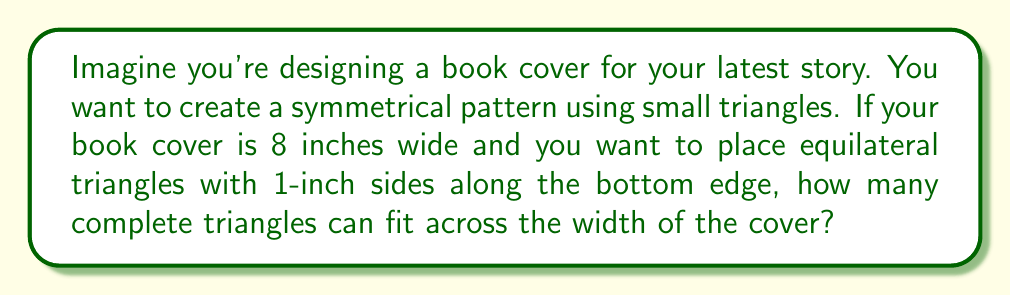Give your solution to this math problem. Let's approach this step-by-step:

1. We need to find out how much space each triangle occupies horizontally.

2. In an equilateral triangle, all sides are equal and all angles are 60°.

3. The width of the triangle is not the same as its side length. We need to calculate it:
   
   [asy]
   import geometry;
   
   size(100);
   
   pair A = (0,0), B = (1,0), C = (0.5, 0.866);
   
   draw(A--B--C--A);
   
   label("1", (B+C)/2, E);
   label("0.5", (0.25, 0), S);
   label("$\frac{\sqrt{3}}{2}$", (0.5,0.433), W);
   
   dot("A", A, SW);
   dot("B", B, SE);
   dot("C", C, N);
   [/asy]

4. The width of each triangle is equal to the side length multiplied by $\cos 30°$:
   
   $\text{Width} = 1 \cdot \cos 30° = 1 \cdot \frac{\sqrt{3}}{2} \approx 0.866$ inches

5. Now we can calculate how many triangles fit in 8 inches:
   
   $\text{Number of triangles} = \frac{\text{Total width}}{\text{Width of one triangle}} = \frac{8}{\frac{\sqrt{3}}{2}}$

6. Simplify:
   $\frac{8}{\frac{\sqrt{3}}{2}} = 8 \cdot \frac{2}{\sqrt{3}} = \frac{16}{\sqrt{3}} \approx 9.24$

7. Since we can only use complete triangles, we round down to 9.
Answer: 9 triangles 